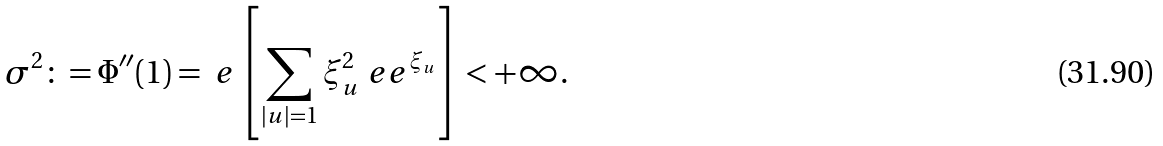Convert formula to latex. <formula><loc_0><loc_0><loc_500><loc_500>\sigma ^ { 2 } \colon = \Phi ^ { \prime \prime } ( 1 ) = \ e \left [ \sum _ { | u | = 1 } \xi _ { u } ^ { 2 } \ e e ^ { \xi _ { u } } \right ] < + \infty .</formula> 